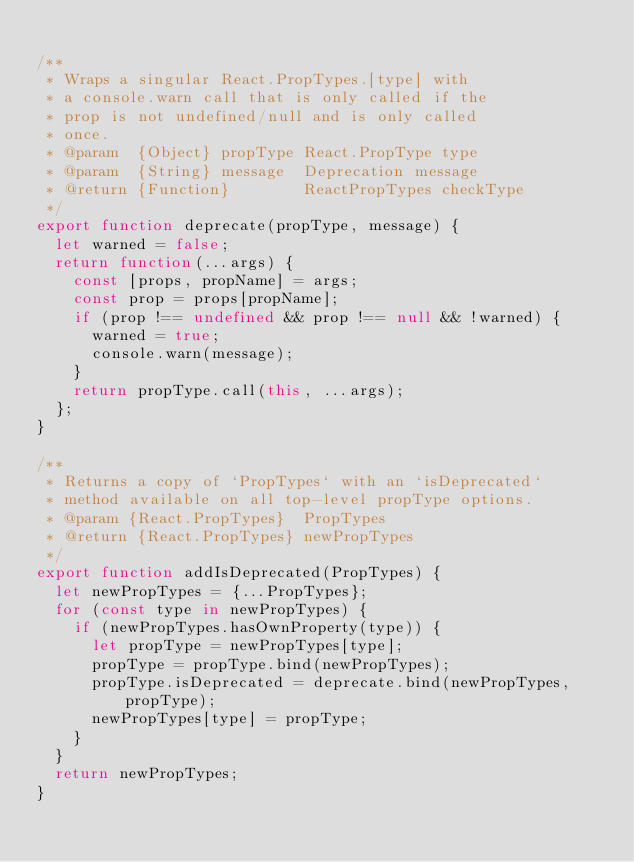<code> <loc_0><loc_0><loc_500><loc_500><_JavaScript_>
/**
 * Wraps a singular React.PropTypes.[type] with
 * a console.warn call that is only called if the
 * prop is not undefined/null and is only called
 * once.
 * @param  {Object} propType React.PropType type
 * @param  {String} message  Deprecation message
 * @return {Function}        ReactPropTypes checkType
 */
export function deprecate(propType, message) {
  let warned = false;
  return function(...args) {
    const [props, propName] = args;
    const prop = props[propName];
    if (prop !== undefined && prop !== null && !warned) {
      warned = true;
      console.warn(message);
    }
    return propType.call(this, ...args);
  };
}

/**
 * Returns a copy of `PropTypes` with an `isDeprecated`
 * method available on all top-level propType options.
 * @param {React.PropTypes}  PropTypes
 * @return {React.PropTypes} newPropTypes
 */
export function addIsDeprecated(PropTypes) {
  let newPropTypes = {...PropTypes};
  for (const type in newPropTypes) {
    if (newPropTypes.hasOwnProperty(type)) {
      let propType = newPropTypes[type];
      propType = propType.bind(newPropTypes);
      propType.isDeprecated = deprecate.bind(newPropTypes, propType);
      newPropTypes[type] = propType;
    }
  }
  return newPropTypes;
}
</code> 